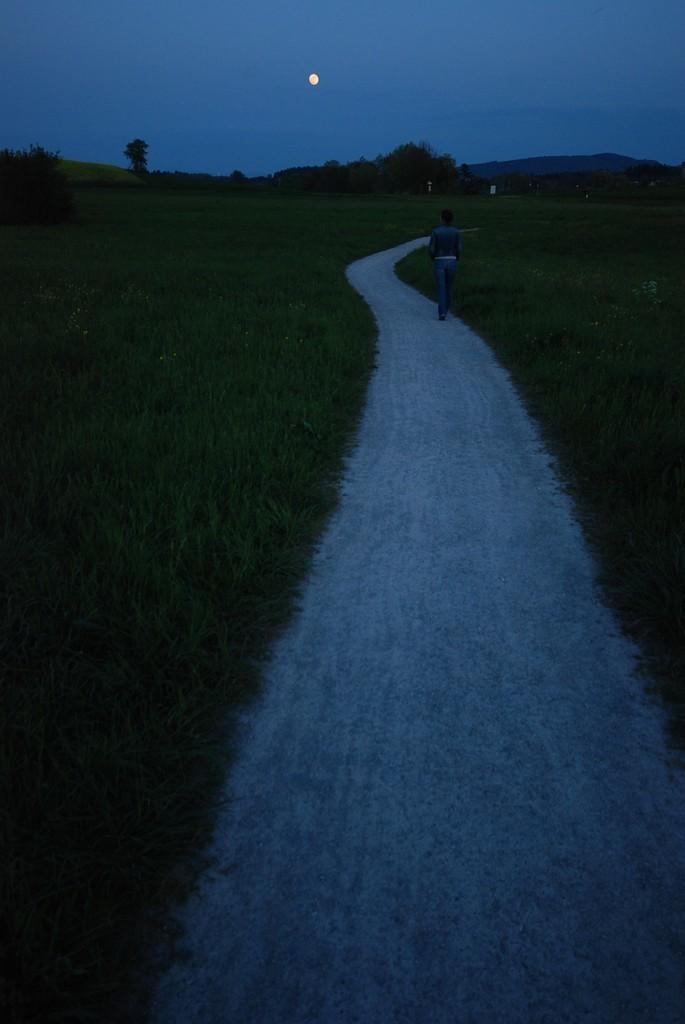In one or two sentences, can you explain what this image depicts? There is a path and greenery in the foreground area of the image, there is a person, trees, it seems like people and a moon in the sky in the background. 